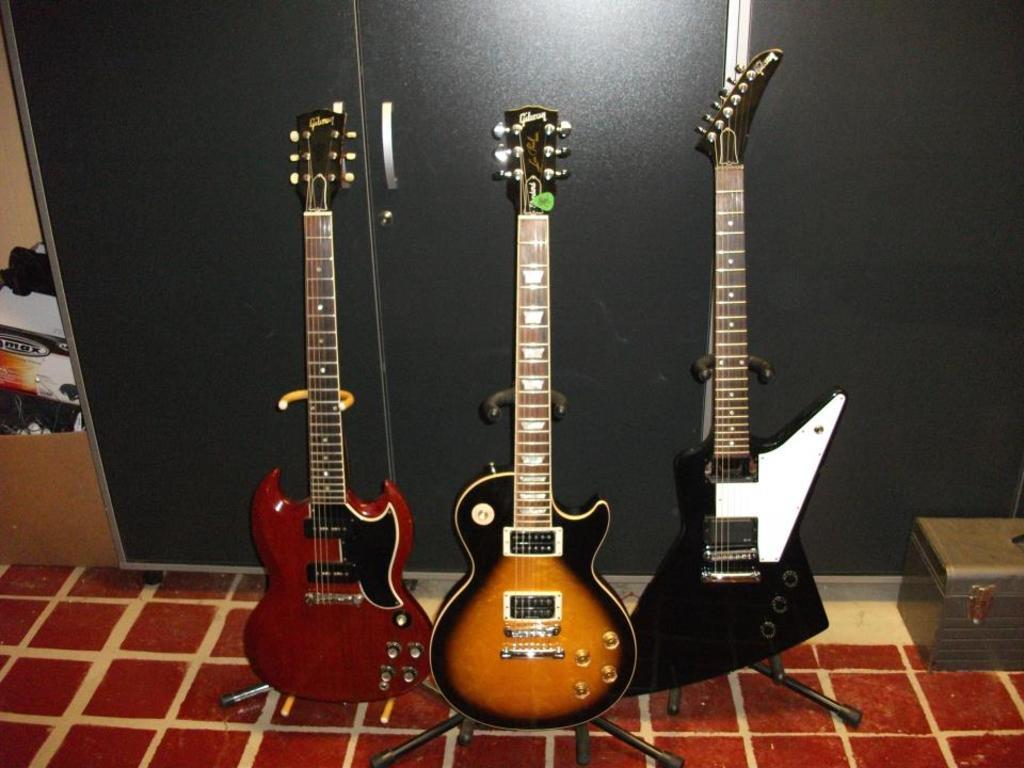Could you give a brief overview of what you see in this image? This image consist of a three guitars kept in the center. At the right side there is one box. In the background there is a grey colour cupboard. 